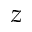Convert formula to latex. <formula><loc_0><loc_0><loc_500><loc_500>z</formula> 